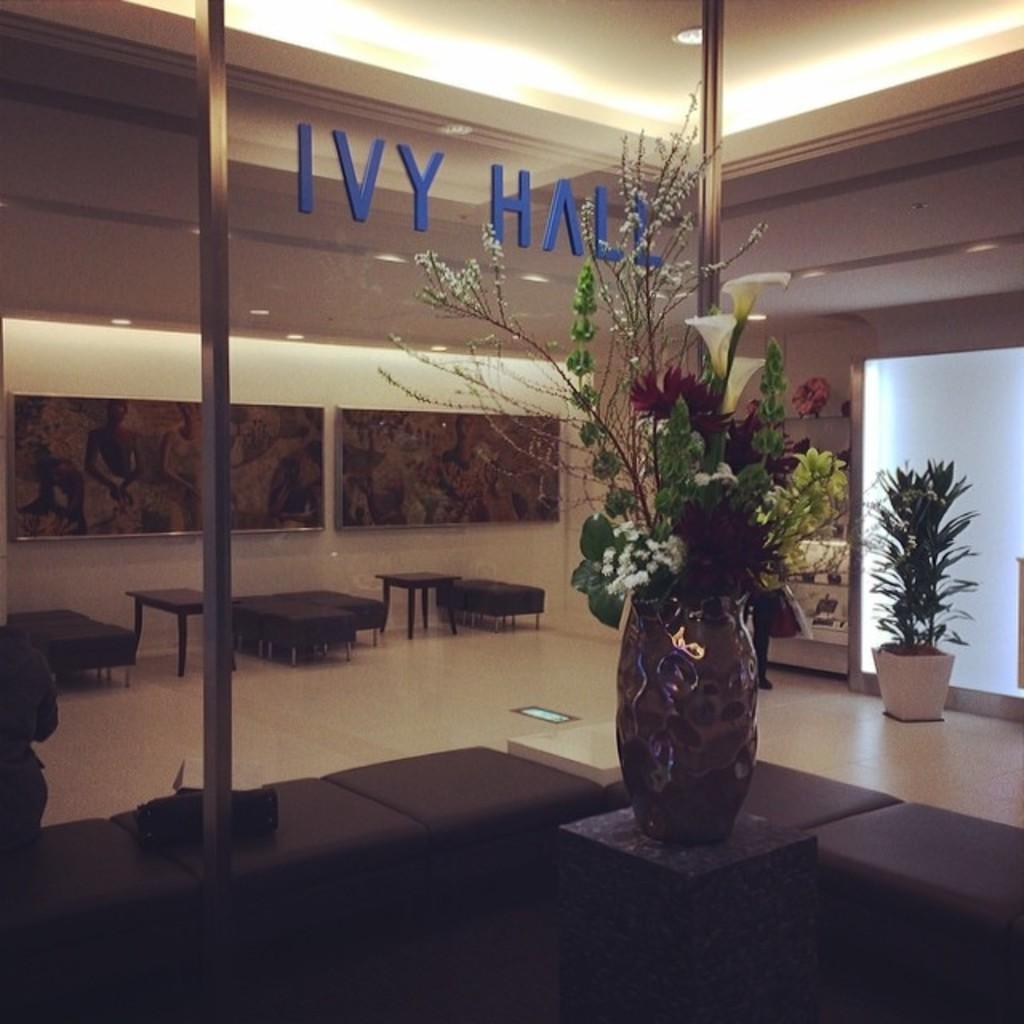Can you describe this image briefly? This is a room. In this room there is a table. On the table there is a vase with many flowers and plants. In the background there are many tables and chairs. Also there is a pot with a plant. And there is a wall with photo frame. There are pillars. And there is a name on the wall. And in the back there is a cupboard. Inside cupboard there are many items kept. 